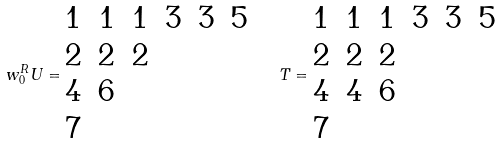<formula> <loc_0><loc_0><loc_500><loc_500>w _ { 0 } ^ { R } U = \begin{matrix} 1 & 1 & 1 & 3 & 3 & 5 \\ 2 & 2 & 2 & & & \\ 4 & 6 & & & & \\ 7 & & & & & \end{matrix} \quad T = \begin{matrix} 1 & 1 & 1 & 3 & 3 & 5 \\ 2 & 2 & 2 & & & \\ 4 & 4 & 6 & & & \\ 7 & & & & & \end{matrix}</formula> 